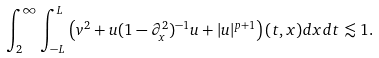Convert formula to latex. <formula><loc_0><loc_0><loc_500><loc_500>\int _ { 2 } ^ { \infty } \int _ { - L } ^ { L } \left ( v ^ { 2 } + u ( 1 - \partial _ { x } ^ { 2 } ) ^ { - 1 } u + | u | ^ { p + 1 } \right ) ( t , x ) d x d t \lesssim 1 .</formula> 